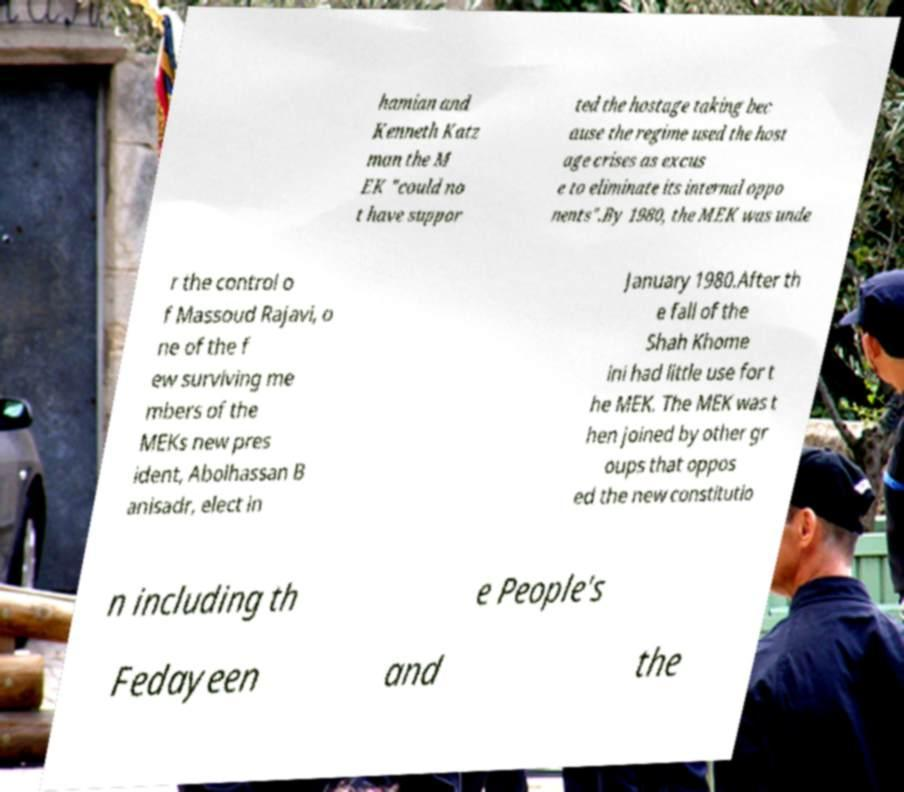Please identify and transcribe the text found in this image. hamian and Kenneth Katz man the M EK "could no t have suppor ted the hostage taking bec ause the regime used the host age crises as excus e to eliminate its internal oppo nents".By 1980, the MEK was unde r the control o f Massoud Rajavi, o ne of the f ew surviving me mbers of the MEKs new pres ident, Abolhassan B anisadr, elect in January 1980.After th e fall of the Shah Khome ini had little use for t he MEK. The MEK was t hen joined by other gr oups that oppos ed the new constitutio n including th e People's Fedayeen and the 